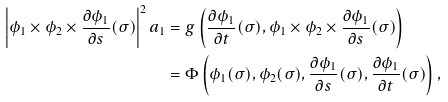<formula> <loc_0><loc_0><loc_500><loc_500>\left | \phi _ { 1 } \times \phi _ { 2 } \times \frac { \partial \phi _ { 1 } } { \partial s } ( \sigma ) \right | ^ { 2 } a _ { 1 } & = g \left ( \frac { \partial \phi _ { 1 } } { \partial t } ( \sigma ) , \phi _ { 1 } \times \phi _ { 2 } \times \frac { \partial \phi _ { 1 } } { \partial s } ( \sigma ) \right ) \\ & = \Phi \left ( \phi _ { 1 } ( \sigma ) , \phi _ { 2 } ( \sigma ) , \frac { \partial \phi _ { 1 } } { \partial s } ( \sigma ) , \frac { \partial \phi _ { 1 } } { \partial t } ( \sigma ) \right ) ,</formula> 